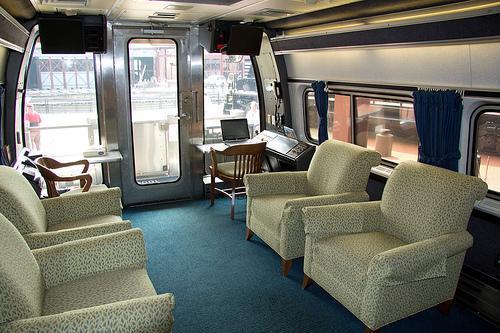How many chairs are pictured?
Give a very brief answer. 6. How many beige chairs are there?
Give a very brief answer. 4. 